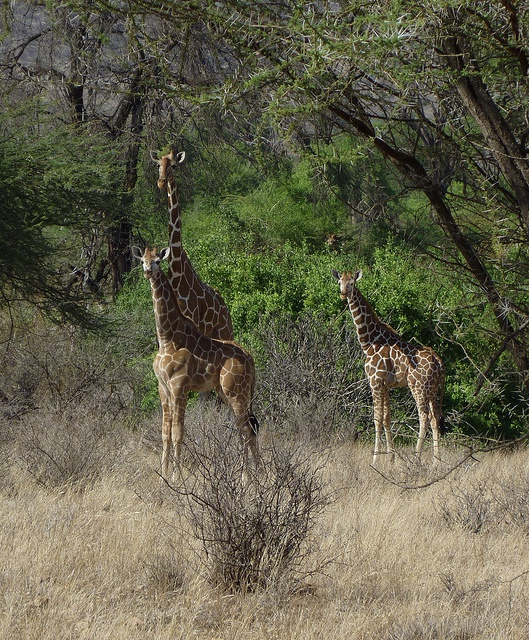Describe the objects in this image and their specific colors. I can see giraffe in gray, black, and maroon tones, giraffe in gray, black, and maroon tones, and giraffe in gray, black, and darkgreen tones in this image. 